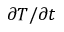Convert formula to latex. <formula><loc_0><loc_0><loc_500><loc_500>\partial T / \partial t</formula> 